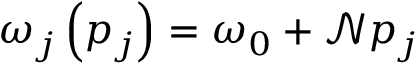Convert formula to latex. <formula><loc_0><loc_0><loc_500><loc_500>\omega _ { j } \left ( p _ { j } \right ) = \omega _ { 0 } + \mathcal { N } p _ { j }</formula> 